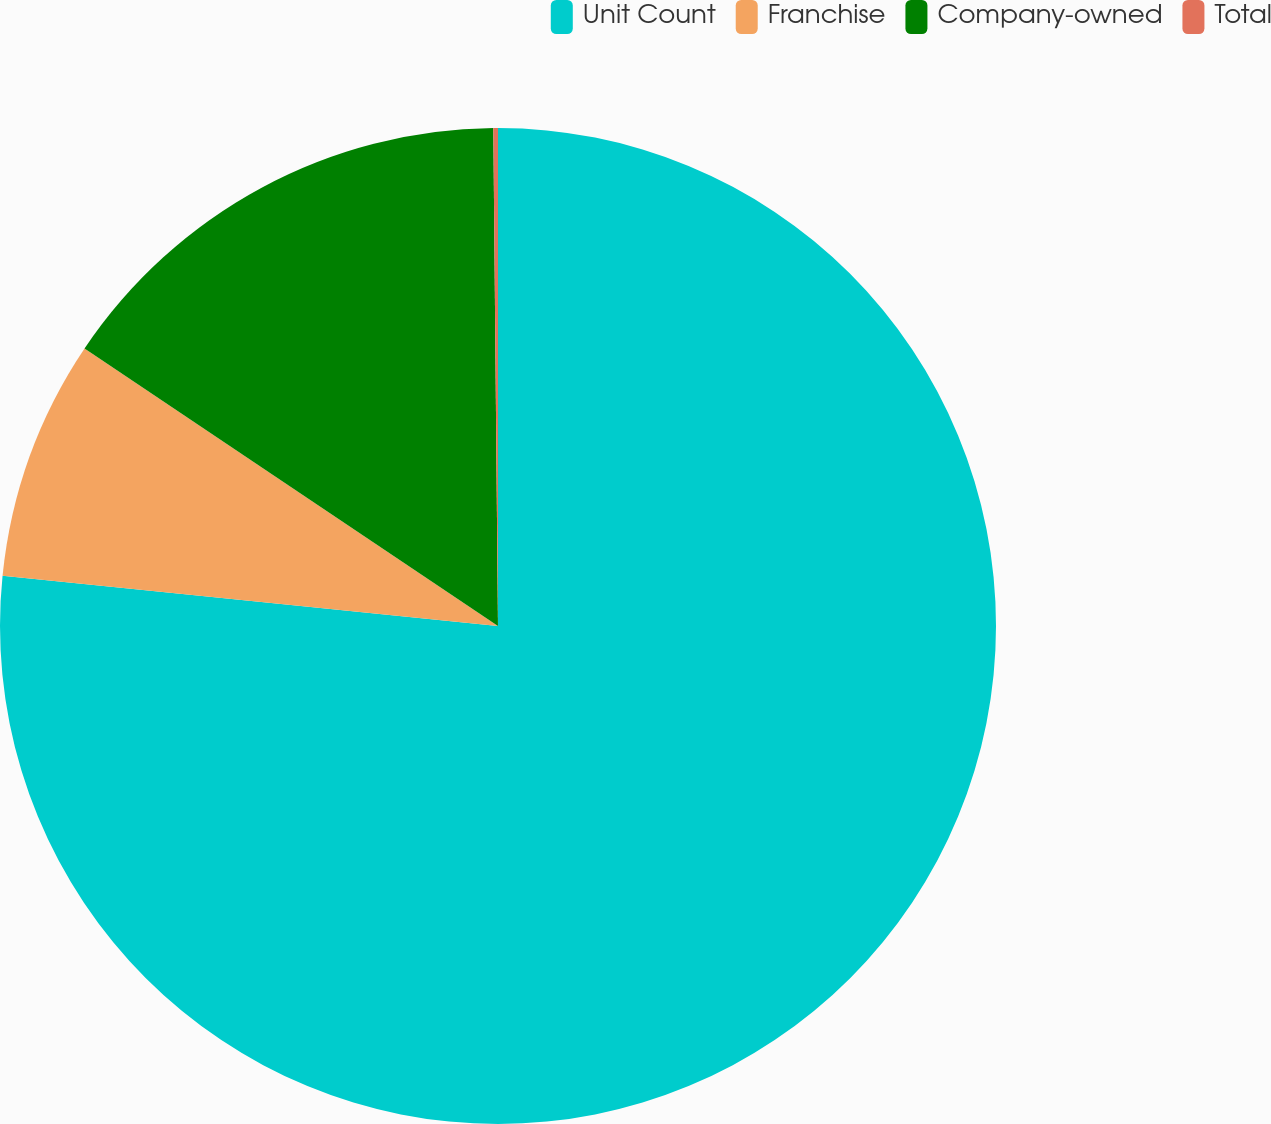Convert chart. <chart><loc_0><loc_0><loc_500><loc_500><pie_chart><fcel>Unit Count<fcel>Franchise<fcel>Company-owned<fcel>Total<nl><fcel>76.61%<fcel>7.8%<fcel>15.44%<fcel>0.15%<nl></chart> 